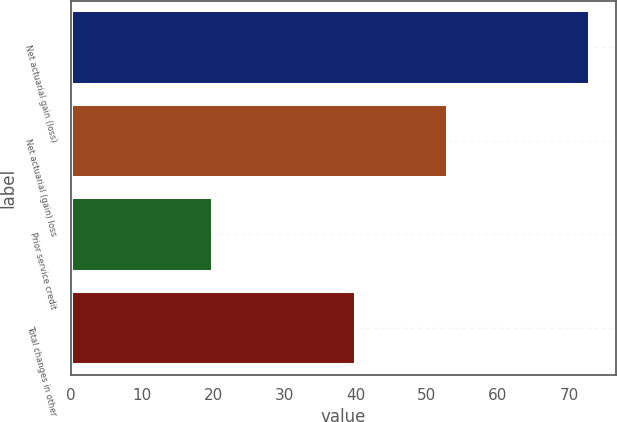Convert chart to OTSL. <chart><loc_0><loc_0><loc_500><loc_500><bar_chart><fcel>Net actuarial gain (loss)<fcel>Net actuarial (gain) loss<fcel>Prior service credit<fcel>Total changes in other<nl><fcel>73<fcel>53<fcel>20<fcel>40<nl></chart> 